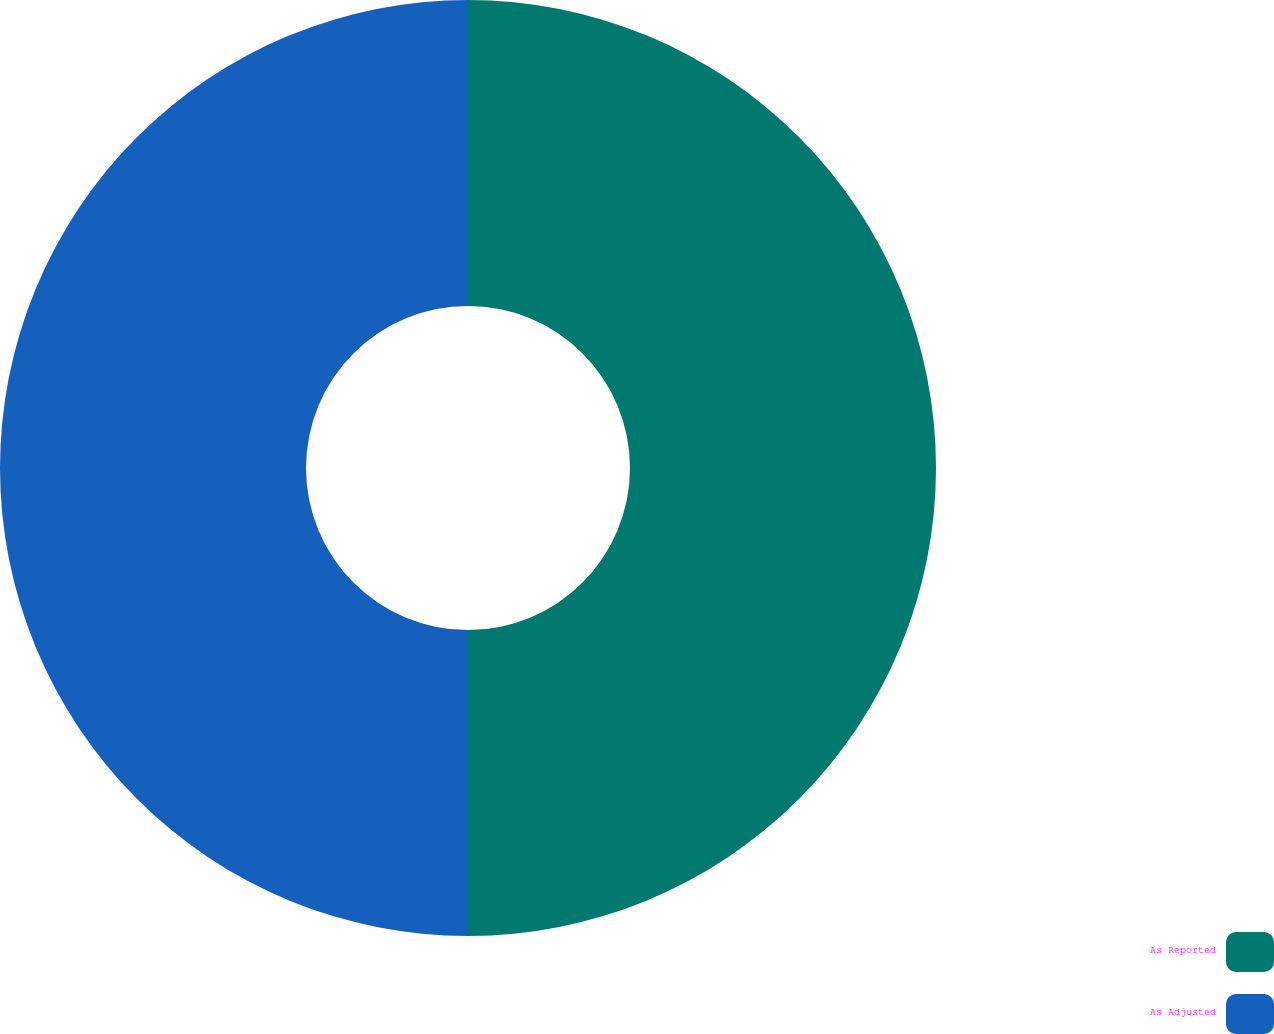Convert chart. <chart><loc_0><loc_0><loc_500><loc_500><pie_chart><fcel>As Reported<fcel>As Adjusted<nl><fcel>50.0%<fcel>50.0%<nl></chart> 